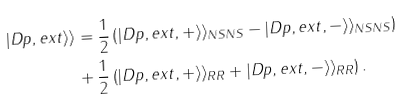Convert formula to latex. <formula><loc_0><loc_0><loc_500><loc_500>| D p , e x t \rangle \rangle & = \frac { 1 } { 2 } \left ( | D p , e x t , + \rangle \rangle _ { N S N S } - | D p , e x t , - \rangle \rangle _ { N S N S } \right ) \\ & + \frac { 1 } { 2 } \left ( | D p , e x t , + \rangle \rangle _ { R R } + | D p , e x t , - \rangle \rangle _ { R R } \right ) .</formula> 